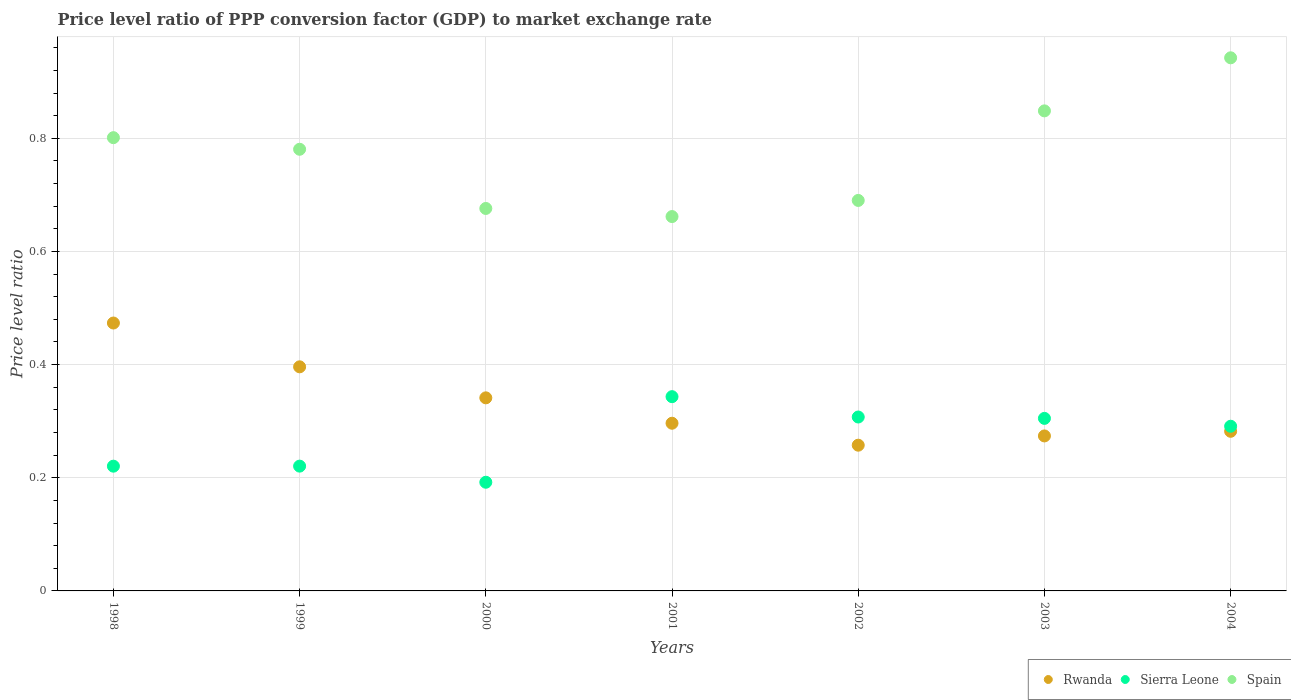How many different coloured dotlines are there?
Your answer should be compact. 3. Is the number of dotlines equal to the number of legend labels?
Ensure brevity in your answer.  Yes. What is the price level ratio in Rwanda in 2004?
Keep it short and to the point. 0.28. Across all years, what is the maximum price level ratio in Spain?
Your response must be concise. 0.94. Across all years, what is the minimum price level ratio in Sierra Leone?
Provide a short and direct response. 0.19. What is the total price level ratio in Spain in the graph?
Provide a short and direct response. 5.4. What is the difference between the price level ratio in Spain in 2000 and that in 2002?
Ensure brevity in your answer.  -0.01. What is the difference between the price level ratio in Spain in 1998 and the price level ratio in Sierra Leone in 2003?
Your answer should be very brief. 0.5. What is the average price level ratio in Rwanda per year?
Keep it short and to the point. 0.33. In the year 1998, what is the difference between the price level ratio in Spain and price level ratio in Sierra Leone?
Keep it short and to the point. 0.58. What is the ratio of the price level ratio in Sierra Leone in 2000 to that in 2004?
Provide a short and direct response. 0.66. What is the difference between the highest and the second highest price level ratio in Rwanda?
Give a very brief answer. 0.08. What is the difference between the highest and the lowest price level ratio in Sierra Leone?
Offer a terse response. 0.15. Is the sum of the price level ratio in Sierra Leone in 2001 and 2004 greater than the maximum price level ratio in Rwanda across all years?
Your answer should be very brief. Yes. Is the price level ratio in Spain strictly greater than the price level ratio in Rwanda over the years?
Provide a short and direct response. Yes. What is the difference between two consecutive major ticks on the Y-axis?
Offer a very short reply. 0.2. What is the title of the graph?
Keep it short and to the point. Price level ratio of PPP conversion factor (GDP) to market exchange rate. Does "Georgia" appear as one of the legend labels in the graph?
Provide a short and direct response. No. What is the label or title of the X-axis?
Keep it short and to the point. Years. What is the label or title of the Y-axis?
Provide a succinct answer. Price level ratio. What is the Price level ratio in Rwanda in 1998?
Provide a short and direct response. 0.47. What is the Price level ratio in Sierra Leone in 1998?
Give a very brief answer. 0.22. What is the Price level ratio in Spain in 1998?
Your response must be concise. 0.8. What is the Price level ratio of Rwanda in 1999?
Ensure brevity in your answer.  0.4. What is the Price level ratio of Sierra Leone in 1999?
Give a very brief answer. 0.22. What is the Price level ratio in Spain in 1999?
Your answer should be very brief. 0.78. What is the Price level ratio of Rwanda in 2000?
Offer a terse response. 0.34. What is the Price level ratio of Sierra Leone in 2000?
Give a very brief answer. 0.19. What is the Price level ratio in Spain in 2000?
Your answer should be compact. 0.68. What is the Price level ratio of Rwanda in 2001?
Your answer should be compact. 0.3. What is the Price level ratio of Sierra Leone in 2001?
Offer a very short reply. 0.34. What is the Price level ratio in Spain in 2001?
Offer a terse response. 0.66. What is the Price level ratio of Rwanda in 2002?
Provide a succinct answer. 0.26. What is the Price level ratio of Sierra Leone in 2002?
Make the answer very short. 0.31. What is the Price level ratio in Spain in 2002?
Your response must be concise. 0.69. What is the Price level ratio of Rwanda in 2003?
Your answer should be compact. 0.27. What is the Price level ratio of Sierra Leone in 2003?
Your answer should be very brief. 0.3. What is the Price level ratio in Spain in 2003?
Your response must be concise. 0.85. What is the Price level ratio of Rwanda in 2004?
Offer a terse response. 0.28. What is the Price level ratio of Sierra Leone in 2004?
Your answer should be compact. 0.29. What is the Price level ratio of Spain in 2004?
Offer a very short reply. 0.94. Across all years, what is the maximum Price level ratio in Rwanda?
Offer a very short reply. 0.47. Across all years, what is the maximum Price level ratio in Sierra Leone?
Give a very brief answer. 0.34. Across all years, what is the maximum Price level ratio in Spain?
Offer a very short reply. 0.94. Across all years, what is the minimum Price level ratio in Rwanda?
Offer a very short reply. 0.26. Across all years, what is the minimum Price level ratio in Sierra Leone?
Offer a very short reply. 0.19. Across all years, what is the minimum Price level ratio in Spain?
Ensure brevity in your answer.  0.66. What is the total Price level ratio of Rwanda in the graph?
Your answer should be compact. 2.32. What is the total Price level ratio of Sierra Leone in the graph?
Offer a very short reply. 1.88. What is the total Price level ratio in Spain in the graph?
Your answer should be compact. 5.4. What is the difference between the Price level ratio in Rwanda in 1998 and that in 1999?
Make the answer very short. 0.08. What is the difference between the Price level ratio of Sierra Leone in 1998 and that in 1999?
Provide a short and direct response. -0. What is the difference between the Price level ratio in Spain in 1998 and that in 1999?
Provide a short and direct response. 0.02. What is the difference between the Price level ratio of Rwanda in 1998 and that in 2000?
Your answer should be very brief. 0.13. What is the difference between the Price level ratio of Sierra Leone in 1998 and that in 2000?
Your response must be concise. 0.03. What is the difference between the Price level ratio in Spain in 1998 and that in 2000?
Make the answer very short. 0.13. What is the difference between the Price level ratio in Rwanda in 1998 and that in 2001?
Your response must be concise. 0.18. What is the difference between the Price level ratio of Sierra Leone in 1998 and that in 2001?
Give a very brief answer. -0.12. What is the difference between the Price level ratio in Spain in 1998 and that in 2001?
Ensure brevity in your answer.  0.14. What is the difference between the Price level ratio of Rwanda in 1998 and that in 2002?
Provide a short and direct response. 0.22. What is the difference between the Price level ratio in Sierra Leone in 1998 and that in 2002?
Make the answer very short. -0.09. What is the difference between the Price level ratio of Spain in 1998 and that in 2002?
Give a very brief answer. 0.11. What is the difference between the Price level ratio in Rwanda in 1998 and that in 2003?
Ensure brevity in your answer.  0.2. What is the difference between the Price level ratio in Sierra Leone in 1998 and that in 2003?
Offer a very short reply. -0.08. What is the difference between the Price level ratio of Spain in 1998 and that in 2003?
Provide a short and direct response. -0.05. What is the difference between the Price level ratio in Rwanda in 1998 and that in 2004?
Provide a succinct answer. 0.19. What is the difference between the Price level ratio of Sierra Leone in 1998 and that in 2004?
Provide a succinct answer. -0.07. What is the difference between the Price level ratio in Spain in 1998 and that in 2004?
Your response must be concise. -0.14. What is the difference between the Price level ratio of Rwanda in 1999 and that in 2000?
Offer a terse response. 0.05. What is the difference between the Price level ratio of Sierra Leone in 1999 and that in 2000?
Ensure brevity in your answer.  0.03. What is the difference between the Price level ratio in Spain in 1999 and that in 2000?
Make the answer very short. 0.1. What is the difference between the Price level ratio in Rwanda in 1999 and that in 2001?
Provide a succinct answer. 0.1. What is the difference between the Price level ratio in Sierra Leone in 1999 and that in 2001?
Offer a very short reply. -0.12. What is the difference between the Price level ratio in Spain in 1999 and that in 2001?
Make the answer very short. 0.12. What is the difference between the Price level ratio of Rwanda in 1999 and that in 2002?
Offer a very short reply. 0.14. What is the difference between the Price level ratio in Sierra Leone in 1999 and that in 2002?
Make the answer very short. -0.09. What is the difference between the Price level ratio of Spain in 1999 and that in 2002?
Offer a terse response. 0.09. What is the difference between the Price level ratio in Rwanda in 1999 and that in 2003?
Keep it short and to the point. 0.12. What is the difference between the Price level ratio of Sierra Leone in 1999 and that in 2003?
Make the answer very short. -0.08. What is the difference between the Price level ratio in Spain in 1999 and that in 2003?
Provide a succinct answer. -0.07. What is the difference between the Price level ratio in Rwanda in 1999 and that in 2004?
Provide a short and direct response. 0.11. What is the difference between the Price level ratio in Sierra Leone in 1999 and that in 2004?
Give a very brief answer. -0.07. What is the difference between the Price level ratio of Spain in 1999 and that in 2004?
Ensure brevity in your answer.  -0.16. What is the difference between the Price level ratio in Rwanda in 2000 and that in 2001?
Offer a terse response. 0.04. What is the difference between the Price level ratio in Sierra Leone in 2000 and that in 2001?
Your answer should be compact. -0.15. What is the difference between the Price level ratio of Spain in 2000 and that in 2001?
Your response must be concise. 0.01. What is the difference between the Price level ratio of Rwanda in 2000 and that in 2002?
Make the answer very short. 0.08. What is the difference between the Price level ratio of Sierra Leone in 2000 and that in 2002?
Offer a very short reply. -0.12. What is the difference between the Price level ratio of Spain in 2000 and that in 2002?
Your answer should be very brief. -0.01. What is the difference between the Price level ratio in Rwanda in 2000 and that in 2003?
Keep it short and to the point. 0.07. What is the difference between the Price level ratio of Sierra Leone in 2000 and that in 2003?
Provide a short and direct response. -0.11. What is the difference between the Price level ratio of Spain in 2000 and that in 2003?
Your answer should be very brief. -0.17. What is the difference between the Price level ratio of Rwanda in 2000 and that in 2004?
Your response must be concise. 0.06. What is the difference between the Price level ratio in Sierra Leone in 2000 and that in 2004?
Your answer should be compact. -0.1. What is the difference between the Price level ratio in Spain in 2000 and that in 2004?
Keep it short and to the point. -0.27. What is the difference between the Price level ratio in Rwanda in 2001 and that in 2002?
Provide a short and direct response. 0.04. What is the difference between the Price level ratio of Sierra Leone in 2001 and that in 2002?
Your response must be concise. 0.04. What is the difference between the Price level ratio in Spain in 2001 and that in 2002?
Give a very brief answer. -0.03. What is the difference between the Price level ratio of Rwanda in 2001 and that in 2003?
Provide a succinct answer. 0.02. What is the difference between the Price level ratio in Sierra Leone in 2001 and that in 2003?
Your answer should be compact. 0.04. What is the difference between the Price level ratio of Spain in 2001 and that in 2003?
Ensure brevity in your answer.  -0.19. What is the difference between the Price level ratio of Rwanda in 2001 and that in 2004?
Your answer should be very brief. 0.01. What is the difference between the Price level ratio in Sierra Leone in 2001 and that in 2004?
Keep it short and to the point. 0.05. What is the difference between the Price level ratio of Spain in 2001 and that in 2004?
Your answer should be very brief. -0.28. What is the difference between the Price level ratio in Rwanda in 2002 and that in 2003?
Give a very brief answer. -0.02. What is the difference between the Price level ratio of Sierra Leone in 2002 and that in 2003?
Give a very brief answer. 0. What is the difference between the Price level ratio in Spain in 2002 and that in 2003?
Your response must be concise. -0.16. What is the difference between the Price level ratio of Rwanda in 2002 and that in 2004?
Give a very brief answer. -0.02. What is the difference between the Price level ratio of Sierra Leone in 2002 and that in 2004?
Your answer should be very brief. 0.02. What is the difference between the Price level ratio in Spain in 2002 and that in 2004?
Keep it short and to the point. -0.25. What is the difference between the Price level ratio in Rwanda in 2003 and that in 2004?
Provide a succinct answer. -0.01. What is the difference between the Price level ratio in Sierra Leone in 2003 and that in 2004?
Your answer should be very brief. 0.01. What is the difference between the Price level ratio in Spain in 2003 and that in 2004?
Offer a very short reply. -0.09. What is the difference between the Price level ratio of Rwanda in 1998 and the Price level ratio of Sierra Leone in 1999?
Your answer should be very brief. 0.25. What is the difference between the Price level ratio of Rwanda in 1998 and the Price level ratio of Spain in 1999?
Your response must be concise. -0.31. What is the difference between the Price level ratio of Sierra Leone in 1998 and the Price level ratio of Spain in 1999?
Your response must be concise. -0.56. What is the difference between the Price level ratio in Rwanda in 1998 and the Price level ratio in Sierra Leone in 2000?
Give a very brief answer. 0.28. What is the difference between the Price level ratio in Rwanda in 1998 and the Price level ratio in Spain in 2000?
Provide a short and direct response. -0.2. What is the difference between the Price level ratio in Sierra Leone in 1998 and the Price level ratio in Spain in 2000?
Your answer should be very brief. -0.46. What is the difference between the Price level ratio in Rwanda in 1998 and the Price level ratio in Sierra Leone in 2001?
Your answer should be compact. 0.13. What is the difference between the Price level ratio in Rwanda in 1998 and the Price level ratio in Spain in 2001?
Keep it short and to the point. -0.19. What is the difference between the Price level ratio of Sierra Leone in 1998 and the Price level ratio of Spain in 2001?
Give a very brief answer. -0.44. What is the difference between the Price level ratio of Rwanda in 1998 and the Price level ratio of Sierra Leone in 2002?
Make the answer very short. 0.17. What is the difference between the Price level ratio in Rwanda in 1998 and the Price level ratio in Spain in 2002?
Your response must be concise. -0.22. What is the difference between the Price level ratio of Sierra Leone in 1998 and the Price level ratio of Spain in 2002?
Your answer should be very brief. -0.47. What is the difference between the Price level ratio of Rwanda in 1998 and the Price level ratio of Sierra Leone in 2003?
Your answer should be very brief. 0.17. What is the difference between the Price level ratio of Rwanda in 1998 and the Price level ratio of Spain in 2003?
Offer a terse response. -0.38. What is the difference between the Price level ratio of Sierra Leone in 1998 and the Price level ratio of Spain in 2003?
Ensure brevity in your answer.  -0.63. What is the difference between the Price level ratio in Rwanda in 1998 and the Price level ratio in Sierra Leone in 2004?
Make the answer very short. 0.18. What is the difference between the Price level ratio in Rwanda in 1998 and the Price level ratio in Spain in 2004?
Provide a succinct answer. -0.47. What is the difference between the Price level ratio in Sierra Leone in 1998 and the Price level ratio in Spain in 2004?
Your answer should be compact. -0.72. What is the difference between the Price level ratio of Rwanda in 1999 and the Price level ratio of Sierra Leone in 2000?
Your answer should be compact. 0.2. What is the difference between the Price level ratio of Rwanda in 1999 and the Price level ratio of Spain in 2000?
Offer a very short reply. -0.28. What is the difference between the Price level ratio of Sierra Leone in 1999 and the Price level ratio of Spain in 2000?
Ensure brevity in your answer.  -0.46. What is the difference between the Price level ratio in Rwanda in 1999 and the Price level ratio in Sierra Leone in 2001?
Your answer should be very brief. 0.05. What is the difference between the Price level ratio of Rwanda in 1999 and the Price level ratio of Spain in 2001?
Your response must be concise. -0.27. What is the difference between the Price level ratio in Sierra Leone in 1999 and the Price level ratio in Spain in 2001?
Offer a terse response. -0.44. What is the difference between the Price level ratio in Rwanda in 1999 and the Price level ratio in Sierra Leone in 2002?
Make the answer very short. 0.09. What is the difference between the Price level ratio in Rwanda in 1999 and the Price level ratio in Spain in 2002?
Make the answer very short. -0.29. What is the difference between the Price level ratio of Sierra Leone in 1999 and the Price level ratio of Spain in 2002?
Provide a succinct answer. -0.47. What is the difference between the Price level ratio of Rwanda in 1999 and the Price level ratio of Sierra Leone in 2003?
Offer a very short reply. 0.09. What is the difference between the Price level ratio of Rwanda in 1999 and the Price level ratio of Spain in 2003?
Your response must be concise. -0.45. What is the difference between the Price level ratio in Sierra Leone in 1999 and the Price level ratio in Spain in 2003?
Your answer should be compact. -0.63. What is the difference between the Price level ratio of Rwanda in 1999 and the Price level ratio of Sierra Leone in 2004?
Offer a terse response. 0.1. What is the difference between the Price level ratio of Rwanda in 1999 and the Price level ratio of Spain in 2004?
Provide a succinct answer. -0.55. What is the difference between the Price level ratio of Sierra Leone in 1999 and the Price level ratio of Spain in 2004?
Provide a short and direct response. -0.72. What is the difference between the Price level ratio in Rwanda in 2000 and the Price level ratio in Sierra Leone in 2001?
Make the answer very short. -0. What is the difference between the Price level ratio in Rwanda in 2000 and the Price level ratio in Spain in 2001?
Ensure brevity in your answer.  -0.32. What is the difference between the Price level ratio of Sierra Leone in 2000 and the Price level ratio of Spain in 2001?
Provide a short and direct response. -0.47. What is the difference between the Price level ratio in Rwanda in 2000 and the Price level ratio in Sierra Leone in 2002?
Your answer should be very brief. 0.03. What is the difference between the Price level ratio of Rwanda in 2000 and the Price level ratio of Spain in 2002?
Your answer should be compact. -0.35. What is the difference between the Price level ratio in Sierra Leone in 2000 and the Price level ratio in Spain in 2002?
Give a very brief answer. -0.5. What is the difference between the Price level ratio of Rwanda in 2000 and the Price level ratio of Sierra Leone in 2003?
Provide a short and direct response. 0.04. What is the difference between the Price level ratio in Rwanda in 2000 and the Price level ratio in Spain in 2003?
Your response must be concise. -0.51. What is the difference between the Price level ratio in Sierra Leone in 2000 and the Price level ratio in Spain in 2003?
Keep it short and to the point. -0.66. What is the difference between the Price level ratio of Rwanda in 2000 and the Price level ratio of Sierra Leone in 2004?
Give a very brief answer. 0.05. What is the difference between the Price level ratio in Rwanda in 2000 and the Price level ratio in Spain in 2004?
Your answer should be very brief. -0.6. What is the difference between the Price level ratio in Sierra Leone in 2000 and the Price level ratio in Spain in 2004?
Ensure brevity in your answer.  -0.75. What is the difference between the Price level ratio of Rwanda in 2001 and the Price level ratio of Sierra Leone in 2002?
Make the answer very short. -0.01. What is the difference between the Price level ratio of Rwanda in 2001 and the Price level ratio of Spain in 2002?
Provide a short and direct response. -0.39. What is the difference between the Price level ratio in Sierra Leone in 2001 and the Price level ratio in Spain in 2002?
Keep it short and to the point. -0.35. What is the difference between the Price level ratio of Rwanda in 2001 and the Price level ratio of Sierra Leone in 2003?
Offer a terse response. -0.01. What is the difference between the Price level ratio of Rwanda in 2001 and the Price level ratio of Spain in 2003?
Provide a succinct answer. -0.55. What is the difference between the Price level ratio of Sierra Leone in 2001 and the Price level ratio of Spain in 2003?
Keep it short and to the point. -0.51. What is the difference between the Price level ratio of Rwanda in 2001 and the Price level ratio of Sierra Leone in 2004?
Your answer should be compact. 0.01. What is the difference between the Price level ratio of Rwanda in 2001 and the Price level ratio of Spain in 2004?
Offer a terse response. -0.65. What is the difference between the Price level ratio in Sierra Leone in 2001 and the Price level ratio in Spain in 2004?
Provide a short and direct response. -0.6. What is the difference between the Price level ratio in Rwanda in 2002 and the Price level ratio in Sierra Leone in 2003?
Keep it short and to the point. -0.05. What is the difference between the Price level ratio in Rwanda in 2002 and the Price level ratio in Spain in 2003?
Keep it short and to the point. -0.59. What is the difference between the Price level ratio in Sierra Leone in 2002 and the Price level ratio in Spain in 2003?
Keep it short and to the point. -0.54. What is the difference between the Price level ratio of Rwanda in 2002 and the Price level ratio of Sierra Leone in 2004?
Offer a terse response. -0.03. What is the difference between the Price level ratio of Rwanda in 2002 and the Price level ratio of Spain in 2004?
Provide a succinct answer. -0.68. What is the difference between the Price level ratio in Sierra Leone in 2002 and the Price level ratio in Spain in 2004?
Make the answer very short. -0.63. What is the difference between the Price level ratio of Rwanda in 2003 and the Price level ratio of Sierra Leone in 2004?
Provide a short and direct response. -0.02. What is the difference between the Price level ratio in Rwanda in 2003 and the Price level ratio in Spain in 2004?
Make the answer very short. -0.67. What is the difference between the Price level ratio of Sierra Leone in 2003 and the Price level ratio of Spain in 2004?
Your answer should be very brief. -0.64. What is the average Price level ratio in Rwanda per year?
Provide a succinct answer. 0.33. What is the average Price level ratio in Sierra Leone per year?
Make the answer very short. 0.27. What is the average Price level ratio in Spain per year?
Offer a very short reply. 0.77. In the year 1998, what is the difference between the Price level ratio of Rwanda and Price level ratio of Sierra Leone?
Provide a succinct answer. 0.25. In the year 1998, what is the difference between the Price level ratio in Rwanda and Price level ratio in Spain?
Your answer should be very brief. -0.33. In the year 1998, what is the difference between the Price level ratio in Sierra Leone and Price level ratio in Spain?
Your response must be concise. -0.58. In the year 1999, what is the difference between the Price level ratio in Rwanda and Price level ratio in Sierra Leone?
Ensure brevity in your answer.  0.18. In the year 1999, what is the difference between the Price level ratio of Rwanda and Price level ratio of Spain?
Your answer should be compact. -0.38. In the year 1999, what is the difference between the Price level ratio in Sierra Leone and Price level ratio in Spain?
Provide a succinct answer. -0.56. In the year 2000, what is the difference between the Price level ratio in Rwanda and Price level ratio in Sierra Leone?
Provide a short and direct response. 0.15. In the year 2000, what is the difference between the Price level ratio in Rwanda and Price level ratio in Spain?
Provide a short and direct response. -0.33. In the year 2000, what is the difference between the Price level ratio of Sierra Leone and Price level ratio of Spain?
Your answer should be compact. -0.48. In the year 2001, what is the difference between the Price level ratio in Rwanda and Price level ratio in Sierra Leone?
Give a very brief answer. -0.05. In the year 2001, what is the difference between the Price level ratio of Rwanda and Price level ratio of Spain?
Offer a very short reply. -0.37. In the year 2001, what is the difference between the Price level ratio of Sierra Leone and Price level ratio of Spain?
Your answer should be compact. -0.32. In the year 2002, what is the difference between the Price level ratio in Rwanda and Price level ratio in Sierra Leone?
Ensure brevity in your answer.  -0.05. In the year 2002, what is the difference between the Price level ratio of Rwanda and Price level ratio of Spain?
Give a very brief answer. -0.43. In the year 2002, what is the difference between the Price level ratio in Sierra Leone and Price level ratio in Spain?
Provide a succinct answer. -0.38. In the year 2003, what is the difference between the Price level ratio of Rwanda and Price level ratio of Sierra Leone?
Ensure brevity in your answer.  -0.03. In the year 2003, what is the difference between the Price level ratio of Rwanda and Price level ratio of Spain?
Your response must be concise. -0.57. In the year 2003, what is the difference between the Price level ratio of Sierra Leone and Price level ratio of Spain?
Offer a terse response. -0.54. In the year 2004, what is the difference between the Price level ratio of Rwanda and Price level ratio of Sierra Leone?
Make the answer very short. -0.01. In the year 2004, what is the difference between the Price level ratio of Rwanda and Price level ratio of Spain?
Keep it short and to the point. -0.66. In the year 2004, what is the difference between the Price level ratio in Sierra Leone and Price level ratio in Spain?
Your answer should be very brief. -0.65. What is the ratio of the Price level ratio in Rwanda in 1998 to that in 1999?
Keep it short and to the point. 1.2. What is the ratio of the Price level ratio of Spain in 1998 to that in 1999?
Ensure brevity in your answer.  1.03. What is the ratio of the Price level ratio in Rwanda in 1998 to that in 2000?
Provide a short and direct response. 1.39. What is the ratio of the Price level ratio of Sierra Leone in 1998 to that in 2000?
Your answer should be compact. 1.15. What is the ratio of the Price level ratio in Spain in 1998 to that in 2000?
Give a very brief answer. 1.19. What is the ratio of the Price level ratio of Rwanda in 1998 to that in 2001?
Ensure brevity in your answer.  1.6. What is the ratio of the Price level ratio of Sierra Leone in 1998 to that in 2001?
Your answer should be compact. 0.64. What is the ratio of the Price level ratio in Spain in 1998 to that in 2001?
Provide a succinct answer. 1.21. What is the ratio of the Price level ratio of Rwanda in 1998 to that in 2002?
Provide a short and direct response. 1.84. What is the ratio of the Price level ratio in Sierra Leone in 1998 to that in 2002?
Provide a short and direct response. 0.72. What is the ratio of the Price level ratio in Spain in 1998 to that in 2002?
Give a very brief answer. 1.16. What is the ratio of the Price level ratio in Rwanda in 1998 to that in 2003?
Provide a short and direct response. 1.73. What is the ratio of the Price level ratio of Sierra Leone in 1998 to that in 2003?
Provide a succinct answer. 0.72. What is the ratio of the Price level ratio in Spain in 1998 to that in 2003?
Keep it short and to the point. 0.94. What is the ratio of the Price level ratio of Rwanda in 1998 to that in 2004?
Your answer should be very brief. 1.68. What is the ratio of the Price level ratio in Sierra Leone in 1998 to that in 2004?
Your answer should be compact. 0.76. What is the ratio of the Price level ratio of Spain in 1998 to that in 2004?
Your answer should be compact. 0.85. What is the ratio of the Price level ratio of Rwanda in 1999 to that in 2000?
Keep it short and to the point. 1.16. What is the ratio of the Price level ratio in Sierra Leone in 1999 to that in 2000?
Offer a very short reply. 1.15. What is the ratio of the Price level ratio in Spain in 1999 to that in 2000?
Provide a succinct answer. 1.15. What is the ratio of the Price level ratio of Rwanda in 1999 to that in 2001?
Keep it short and to the point. 1.34. What is the ratio of the Price level ratio in Sierra Leone in 1999 to that in 2001?
Offer a very short reply. 0.64. What is the ratio of the Price level ratio in Spain in 1999 to that in 2001?
Offer a terse response. 1.18. What is the ratio of the Price level ratio of Rwanda in 1999 to that in 2002?
Keep it short and to the point. 1.54. What is the ratio of the Price level ratio in Sierra Leone in 1999 to that in 2002?
Your answer should be very brief. 0.72. What is the ratio of the Price level ratio of Spain in 1999 to that in 2002?
Your answer should be compact. 1.13. What is the ratio of the Price level ratio of Rwanda in 1999 to that in 2003?
Your response must be concise. 1.45. What is the ratio of the Price level ratio of Sierra Leone in 1999 to that in 2003?
Ensure brevity in your answer.  0.72. What is the ratio of the Price level ratio in Spain in 1999 to that in 2003?
Your answer should be very brief. 0.92. What is the ratio of the Price level ratio in Rwanda in 1999 to that in 2004?
Provide a short and direct response. 1.4. What is the ratio of the Price level ratio in Sierra Leone in 1999 to that in 2004?
Provide a short and direct response. 0.76. What is the ratio of the Price level ratio of Spain in 1999 to that in 2004?
Provide a succinct answer. 0.83. What is the ratio of the Price level ratio in Rwanda in 2000 to that in 2001?
Make the answer very short. 1.15. What is the ratio of the Price level ratio of Sierra Leone in 2000 to that in 2001?
Your answer should be very brief. 0.56. What is the ratio of the Price level ratio in Spain in 2000 to that in 2001?
Keep it short and to the point. 1.02. What is the ratio of the Price level ratio in Rwanda in 2000 to that in 2002?
Give a very brief answer. 1.32. What is the ratio of the Price level ratio of Sierra Leone in 2000 to that in 2002?
Your response must be concise. 0.62. What is the ratio of the Price level ratio of Spain in 2000 to that in 2002?
Ensure brevity in your answer.  0.98. What is the ratio of the Price level ratio of Rwanda in 2000 to that in 2003?
Your response must be concise. 1.25. What is the ratio of the Price level ratio of Sierra Leone in 2000 to that in 2003?
Give a very brief answer. 0.63. What is the ratio of the Price level ratio in Spain in 2000 to that in 2003?
Make the answer very short. 0.8. What is the ratio of the Price level ratio of Rwanda in 2000 to that in 2004?
Make the answer very short. 1.21. What is the ratio of the Price level ratio in Sierra Leone in 2000 to that in 2004?
Your answer should be very brief. 0.66. What is the ratio of the Price level ratio in Spain in 2000 to that in 2004?
Ensure brevity in your answer.  0.72. What is the ratio of the Price level ratio in Rwanda in 2001 to that in 2002?
Provide a succinct answer. 1.15. What is the ratio of the Price level ratio of Sierra Leone in 2001 to that in 2002?
Give a very brief answer. 1.12. What is the ratio of the Price level ratio in Spain in 2001 to that in 2002?
Your response must be concise. 0.96. What is the ratio of the Price level ratio in Rwanda in 2001 to that in 2003?
Keep it short and to the point. 1.08. What is the ratio of the Price level ratio of Sierra Leone in 2001 to that in 2003?
Offer a very short reply. 1.13. What is the ratio of the Price level ratio of Spain in 2001 to that in 2003?
Make the answer very short. 0.78. What is the ratio of the Price level ratio of Rwanda in 2001 to that in 2004?
Give a very brief answer. 1.05. What is the ratio of the Price level ratio of Sierra Leone in 2001 to that in 2004?
Your answer should be very brief. 1.18. What is the ratio of the Price level ratio of Spain in 2001 to that in 2004?
Give a very brief answer. 0.7. What is the ratio of the Price level ratio in Rwanda in 2002 to that in 2003?
Your answer should be compact. 0.94. What is the ratio of the Price level ratio in Sierra Leone in 2002 to that in 2003?
Ensure brevity in your answer.  1.01. What is the ratio of the Price level ratio in Spain in 2002 to that in 2003?
Give a very brief answer. 0.81. What is the ratio of the Price level ratio of Sierra Leone in 2002 to that in 2004?
Keep it short and to the point. 1.06. What is the ratio of the Price level ratio of Spain in 2002 to that in 2004?
Provide a short and direct response. 0.73. What is the ratio of the Price level ratio of Rwanda in 2003 to that in 2004?
Make the answer very short. 0.97. What is the ratio of the Price level ratio in Sierra Leone in 2003 to that in 2004?
Keep it short and to the point. 1.05. What is the ratio of the Price level ratio of Spain in 2003 to that in 2004?
Ensure brevity in your answer.  0.9. What is the difference between the highest and the second highest Price level ratio in Rwanda?
Provide a short and direct response. 0.08. What is the difference between the highest and the second highest Price level ratio in Sierra Leone?
Keep it short and to the point. 0.04. What is the difference between the highest and the second highest Price level ratio of Spain?
Your response must be concise. 0.09. What is the difference between the highest and the lowest Price level ratio of Rwanda?
Your response must be concise. 0.22. What is the difference between the highest and the lowest Price level ratio in Sierra Leone?
Provide a succinct answer. 0.15. What is the difference between the highest and the lowest Price level ratio of Spain?
Give a very brief answer. 0.28. 